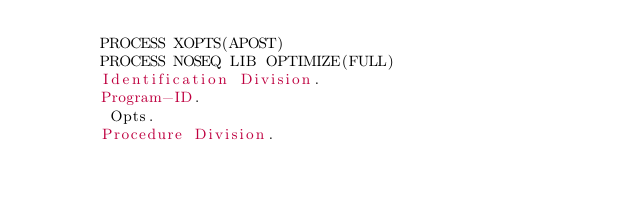Convert code to text. <code><loc_0><loc_0><loc_500><loc_500><_COBOL_>       PROCESS XOPTS(APOST)
       PROCESS NOSEQ LIB OPTIMIZE(FULL)
       Identification Division.
       Program-ID. 
        Opts.
       Procedure Division.</code> 